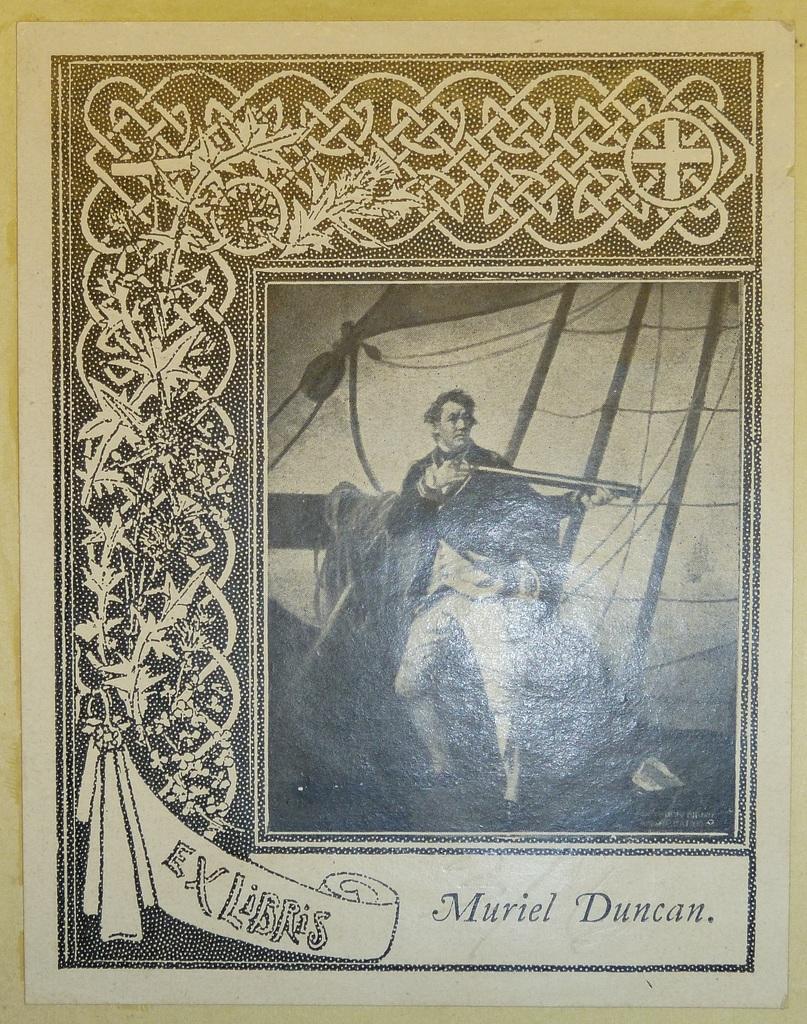Can you describe this image briefly? This is a painting,in this picture we can see a person. 